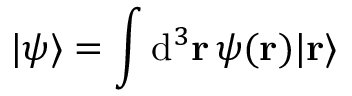Convert formula to latex. <formula><loc_0><loc_0><loc_500><loc_500>| \psi \rangle = \int d ^ { 3 } r \, \psi ( r ) | r \rangle</formula> 